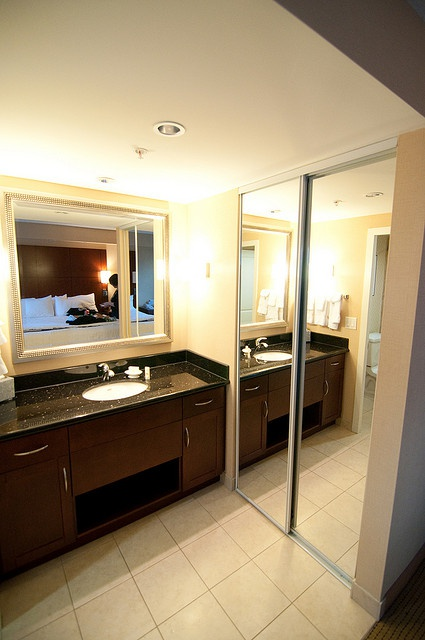Describe the objects in this image and their specific colors. I can see bed in gray, darkgray, lightblue, black, and tan tones, sink in gray, ivory, tan, and olive tones, and sink in gray, ivory, khaki, and tan tones in this image. 